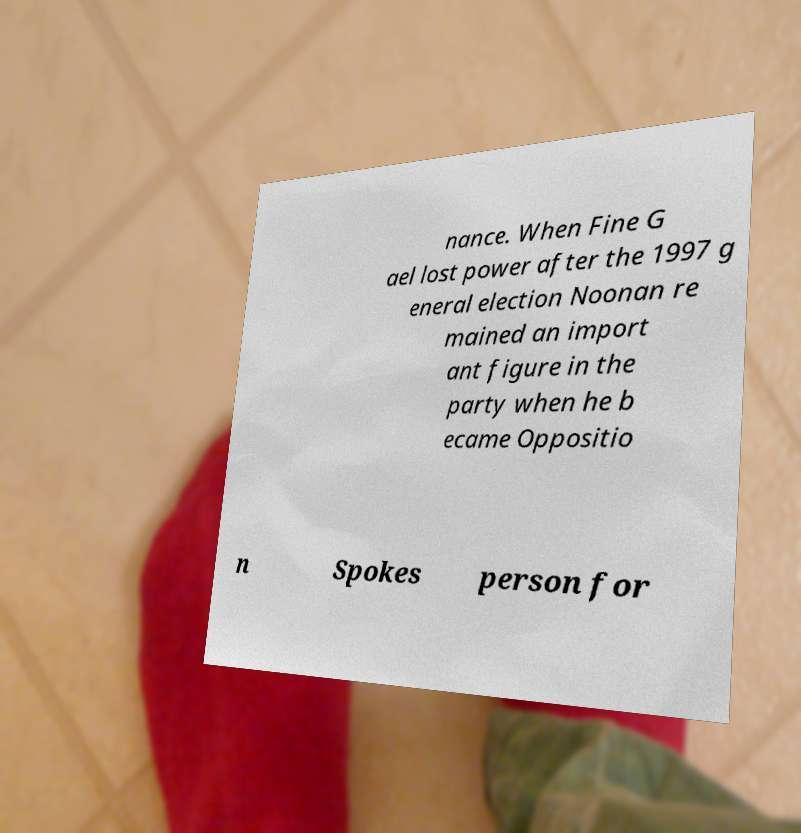Can you read and provide the text displayed in the image?This photo seems to have some interesting text. Can you extract and type it out for me? nance. When Fine G ael lost power after the 1997 g eneral election Noonan re mained an import ant figure in the party when he b ecame Oppositio n Spokes person for 